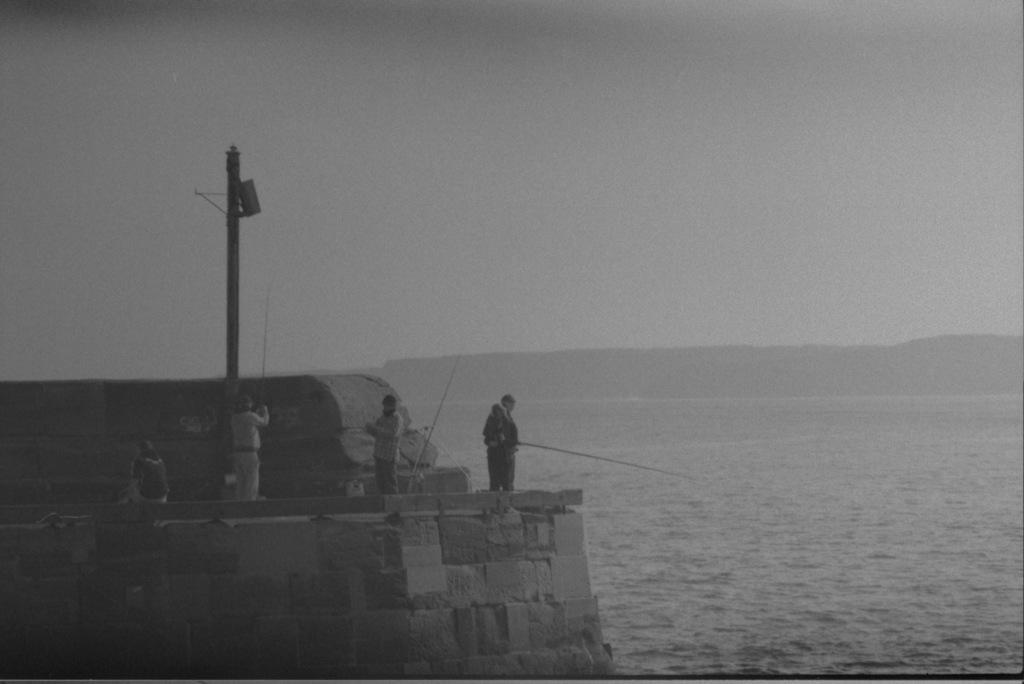In one or two sentences, can you explain what this image depicts? There are people and we can see wall,water and pole. In the background we can see sky. 